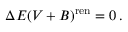Convert formula to latex. <formula><loc_0><loc_0><loc_500><loc_500>\Delta E ( V + B ) ^ { r e n } = 0 \, .</formula> 